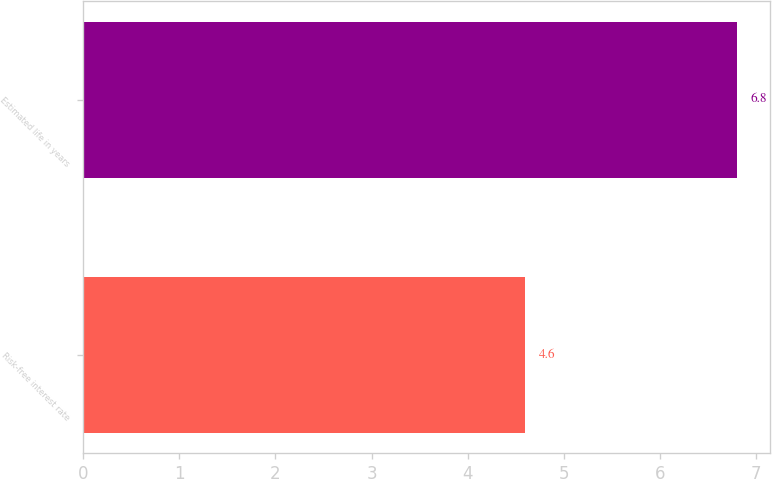Convert chart. <chart><loc_0><loc_0><loc_500><loc_500><bar_chart><fcel>Risk-free interest rate<fcel>Estimated life in years<nl><fcel>4.6<fcel>6.8<nl></chart> 